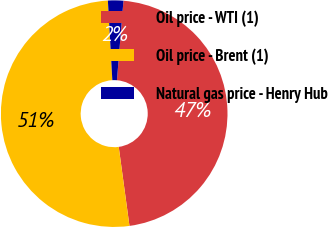Convert chart to OTSL. <chart><loc_0><loc_0><loc_500><loc_500><pie_chart><fcel>Oil price - WTI (1)<fcel>Oil price - Brent (1)<fcel>Natural gas price - Henry Hub<nl><fcel>46.55%<fcel>51.27%<fcel>2.19%<nl></chart> 